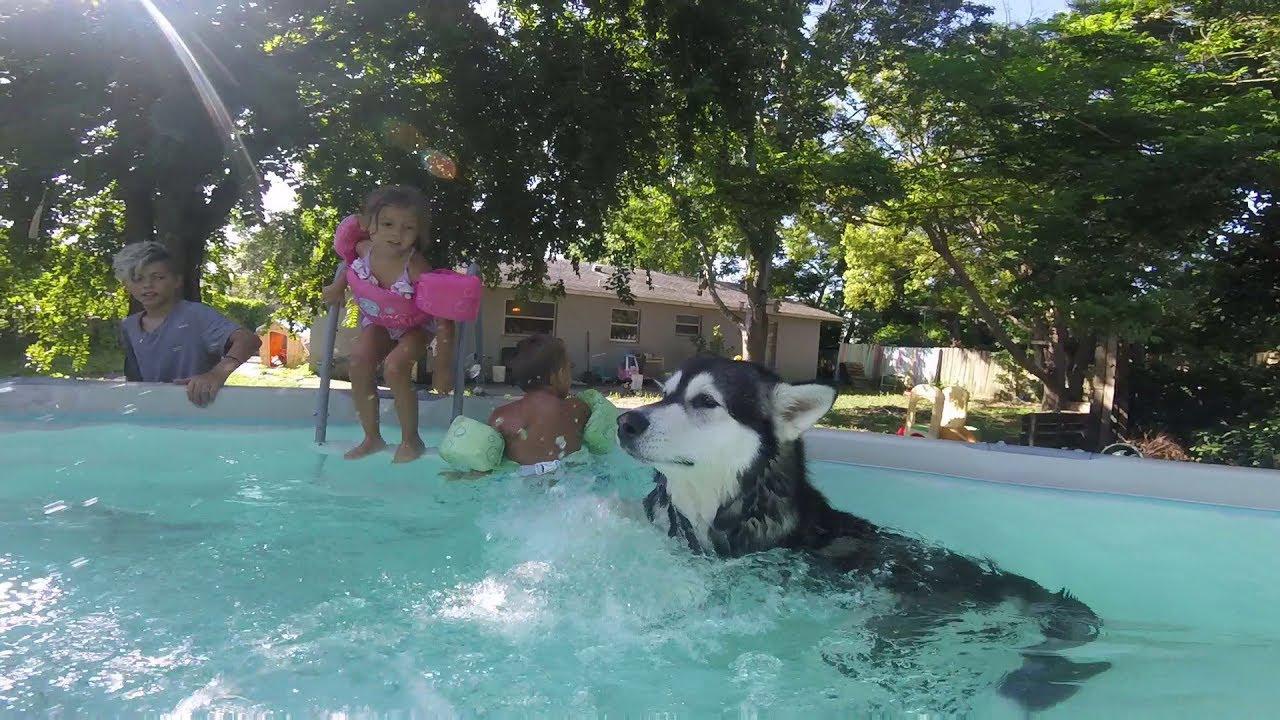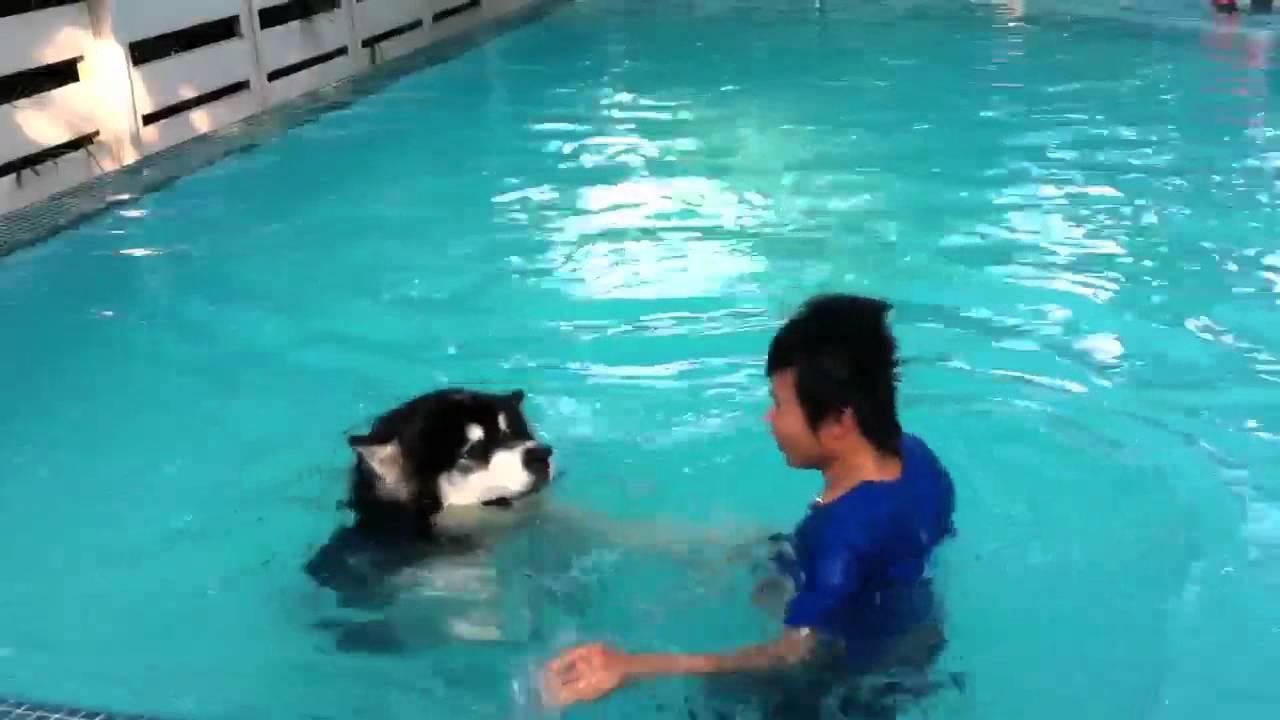The first image is the image on the left, the second image is the image on the right. Assess this claim about the two images: "In one image, a dog is alone in shallow pool water, but in the second image, a dog is with a man in deeper water.". Correct or not? Answer yes or no. No. The first image is the image on the left, the second image is the image on the right. Assess this claim about the two images: "In at least one image there is a husky swimming in a pool with a man only wearing shorts.". Correct or not? Answer yes or no. No. 